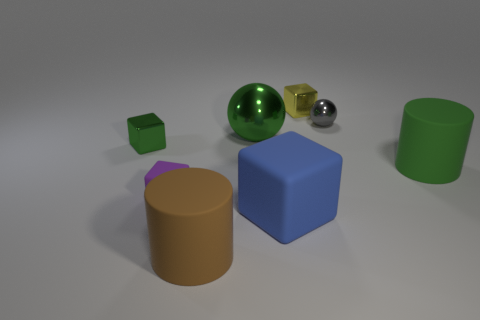Do the gray thing and the purple rubber block in front of the green matte cylinder have the same size?
Make the answer very short. Yes. There is a ball that is on the left side of the small thing that is right of the yellow metal object; what is it made of?
Your answer should be very brief. Metal. What is the size of the shiny sphere right of the shiny block behind the shiny block on the left side of the big green sphere?
Offer a terse response. Small. There is a tiny gray object; does it have the same shape as the thing behind the gray shiny object?
Your answer should be very brief. No. What is the small gray sphere made of?
Offer a very short reply. Metal. How many matte things are either cylinders or big brown objects?
Make the answer very short. 2. Are there fewer objects behind the large shiny thing than green things behind the large blue rubber object?
Offer a terse response. Yes. Is there a small purple matte block that is on the left side of the large matte cylinder that is behind the large matte cylinder on the left side of the big green rubber cylinder?
Your response must be concise. Yes. What is the material of the block that is the same color as the large ball?
Provide a short and direct response. Metal. There is a tiny shiny thing to the left of the brown matte cylinder; does it have the same shape as the big green object that is to the left of the small metal ball?
Offer a terse response. No. 